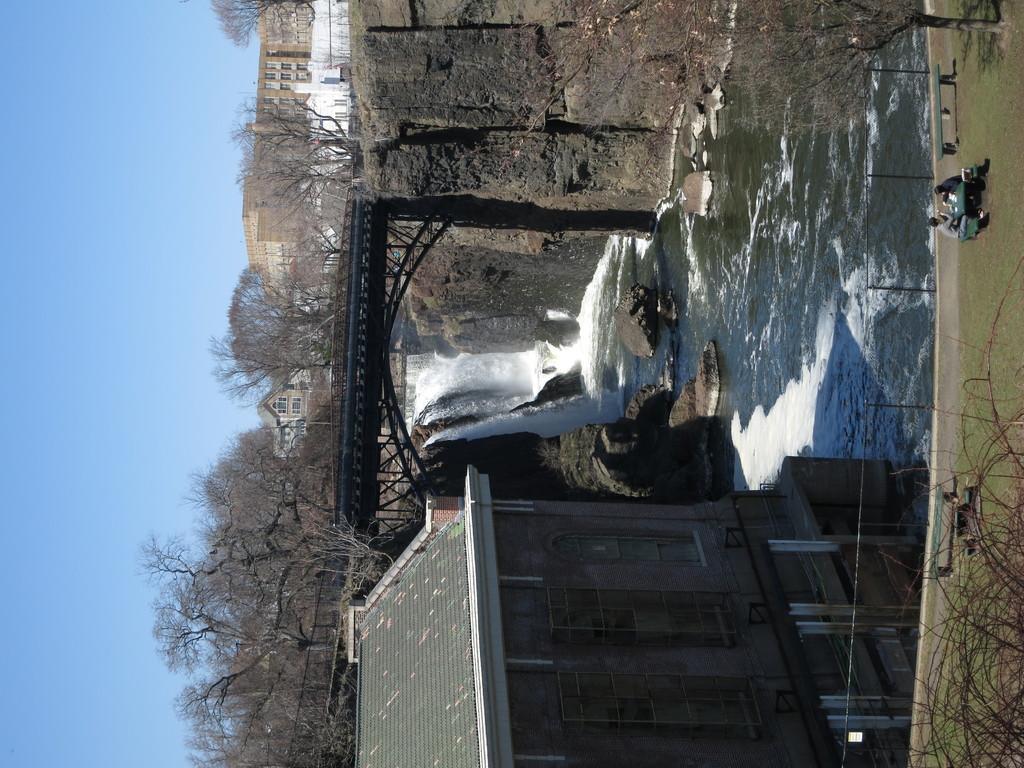Describe this image in one or two sentences. This picture shows few buildings and we see trees and water flowing and we see couple of them seated on the bench and we see a metal fence and couple of benches on the side and a blue sky. 